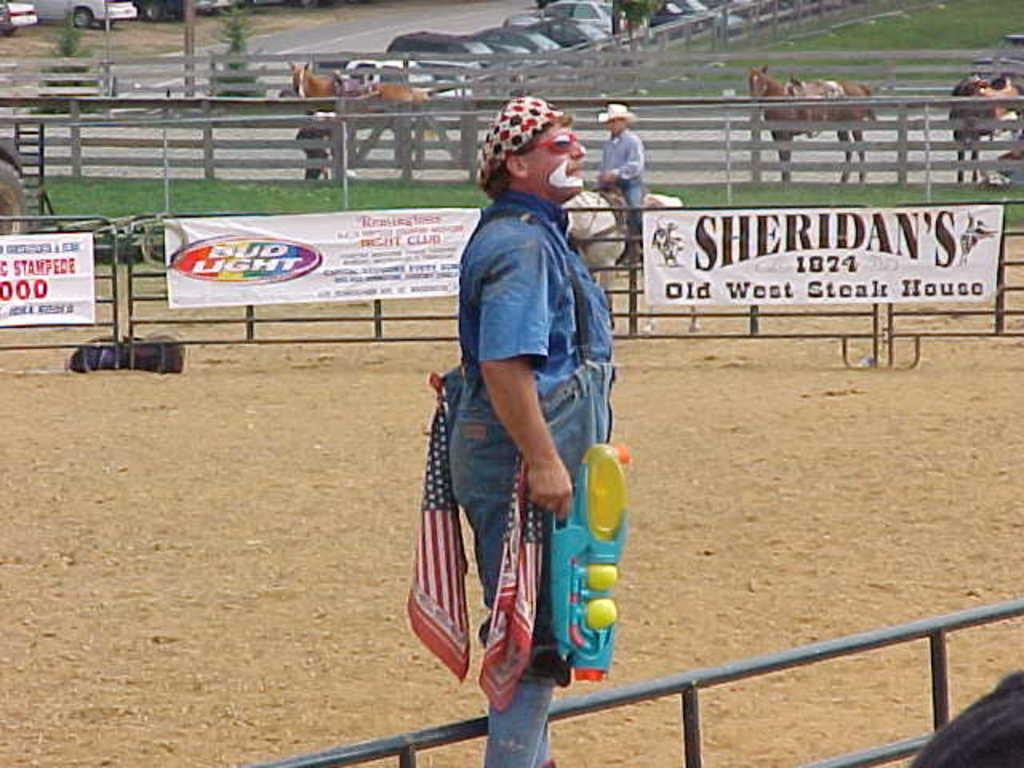What is the man in the image doing with his hand? The man is holding a gun in his hand. What is the other man in the image doing? The other man is riding a horse in the image. How many horses are visible in the image? There are horses visible in the image. What type of vehicles are parked in the image? There are parked cars in the image. What type of oil is being used by the man's mother in the image? There is no mention of a mother or oil in the image, so it cannot be determined. 